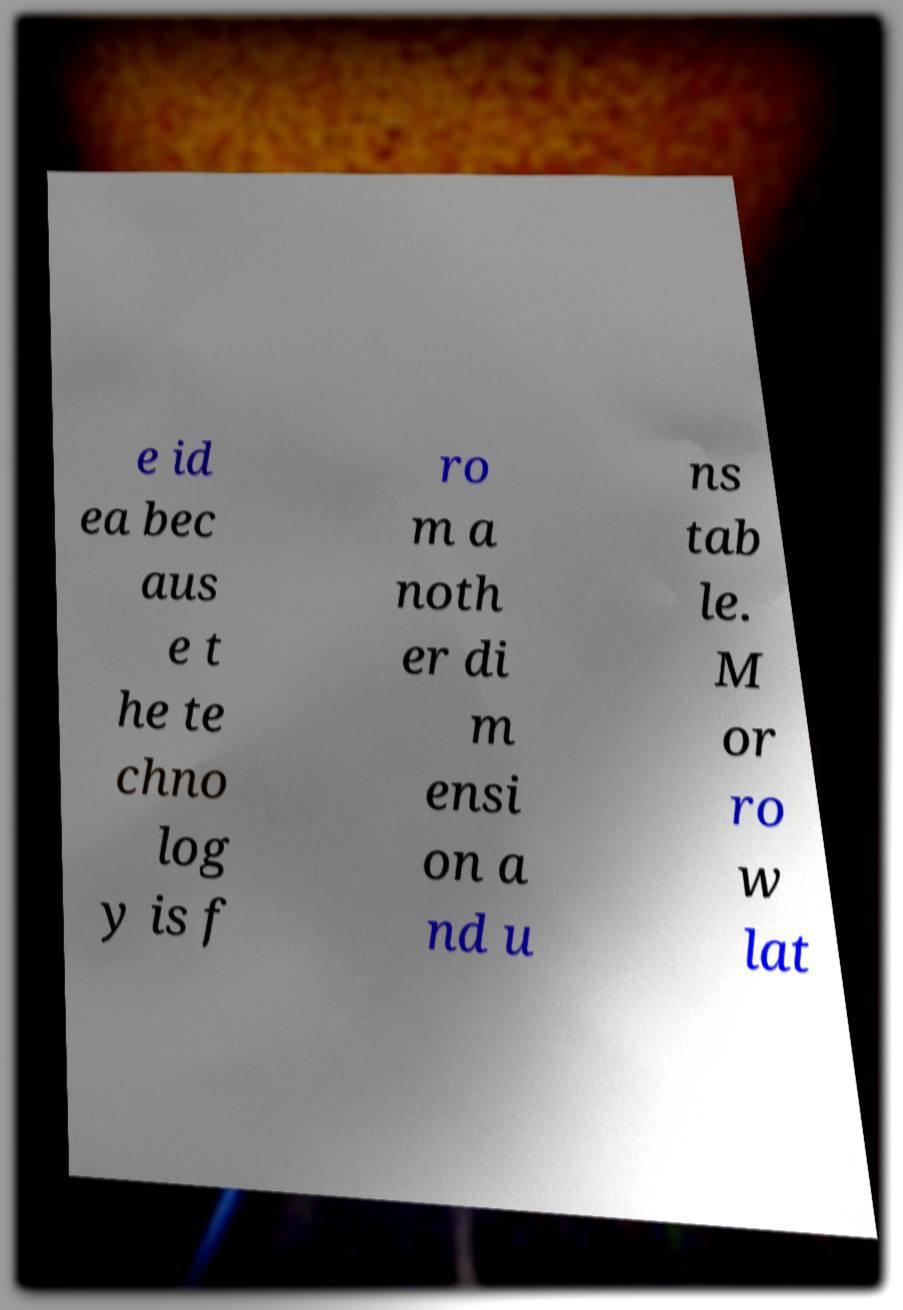What messages or text are displayed in this image? I need them in a readable, typed format. e id ea bec aus e t he te chno log y is f ro m a noth er di m ensi on a nd u ns tab le. M or ro w lat 